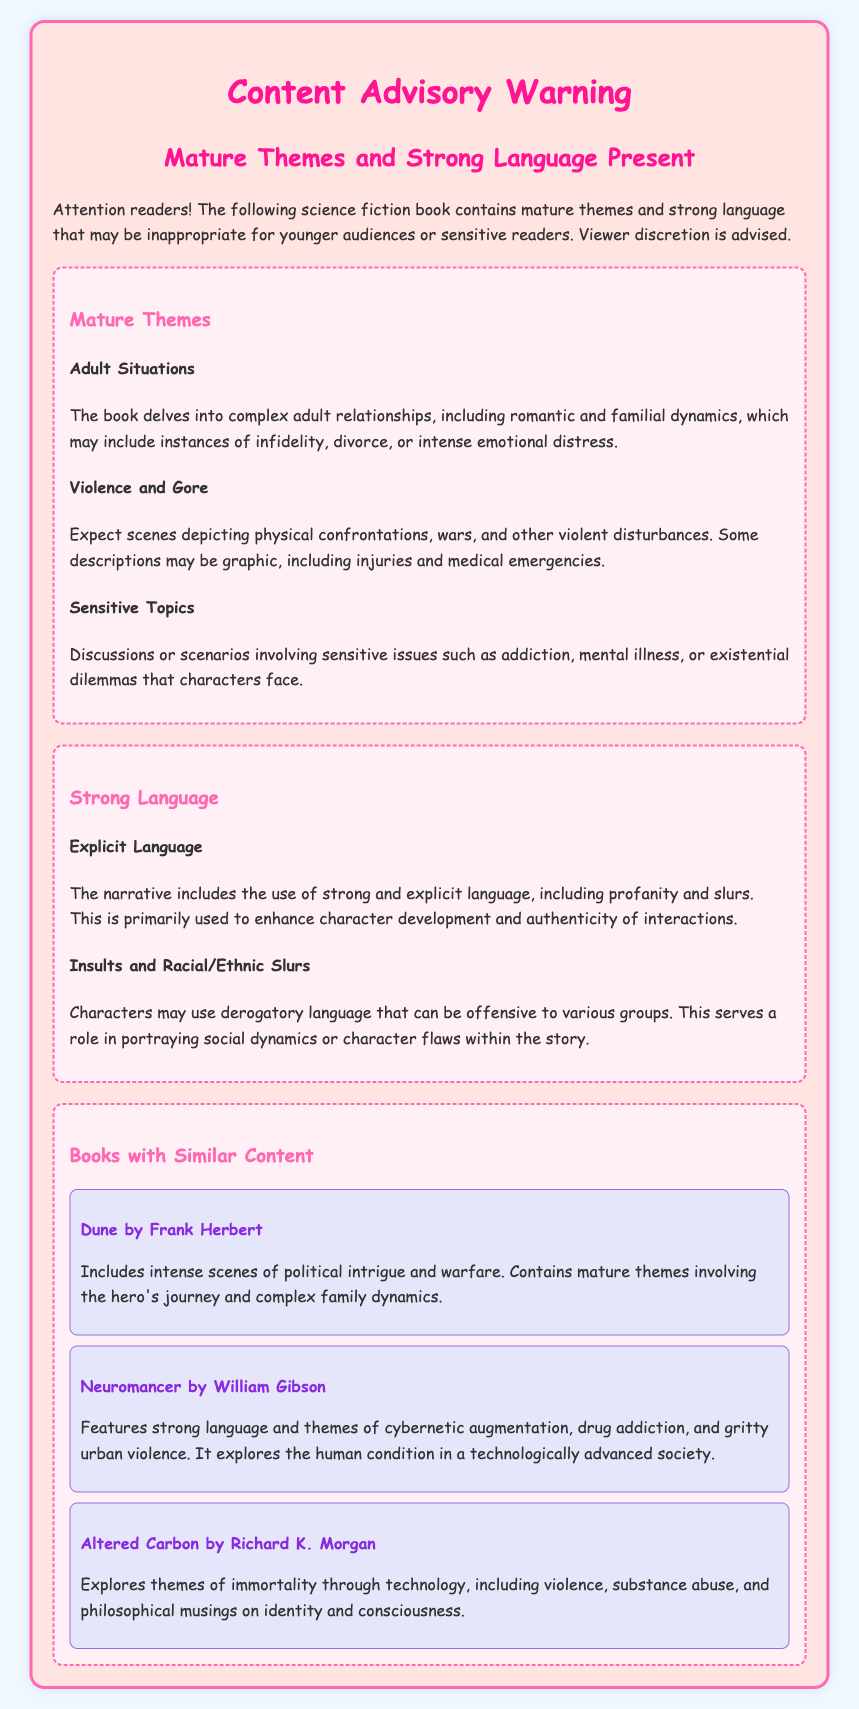What does the warning signify? The warning signifies that the book contains mature themes and strong language that may be inappropriate for younger audiences or sensitive readers.
Answer: Mature themes and strong language What is one example of a mature theme mentioned? The document lists specific mature themes such as adult situations, violence and gore, and sensitive topics.
Answer: Adult situations Which book is mentioned alongside themes of political intrigue? The document lists "Dune" by Frank Herbert as a book that includes intense scenes of political intrigue and warfare.
Answer: Dune by Frank Herbert How is strong language used in the narrative? The document states that strong and explicit language, including profanity and slurs, is used to enhance character development and authenticity of interactions.
Answer: To enhance character development What is one sensitive topic discussed in the book? The document mentions discussions involving sensitive issues such as addiction, mental illness, or existential dilemmas.
Answer: Addiction How many books with similar content are provided as examples? The document lists three books that contain similar content.
Answer: Three What type of language may be considered offensive in the book? The document specifies that characters may use derogatory language that can be offensive to various groups, including insults and racial/ethnic slurs.
Answer: Derogatory language What is the background color of the document? The document has a background color of light blue (#f0f8ff).
Answer: Light blue What is the style of the font used in the document? The document uses 'Comic Sans MS' as the font style.
Answer: Comic Sans MS 